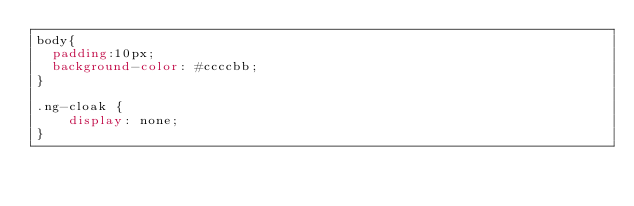Convert code to text. <code><loc_0><loc_0><loc_500><loc_500><_CSS_>body{
	padding:10px;
	background-color: #ccccbb;
}

.ng-cloak {
    display: none;
}</code> 